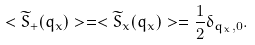<formula> <loc_0><loc_0><loc_500><loc_500>< \widetilde { S } _ { + } ( q _ { x } ) > = < \widetilde { S } _ { x } ( q _ { x } ) > = \frac { 1 } { 2 } \delta _ { q _ { x } , 0 } .</formula> 